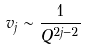Convert formula to latex. <formula><loc_0><loc_0><loc_500><loc_500>v _ { j } \sim \frac { 1 } { Q ^ { 2 j - 2 } }</formula> 